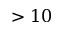Convert formula to latex. <formula><loc_0><loc_0><loc_500><loc_500>> 1 0</formula> 